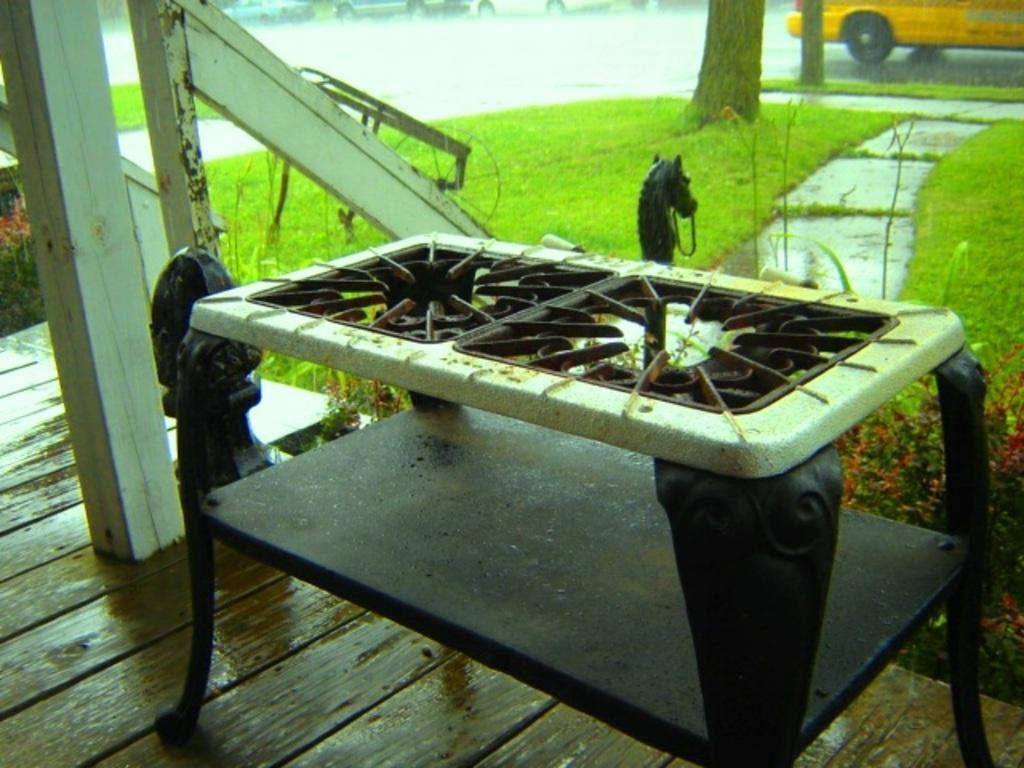Can you describe this image briefly? This picture is clicked outside. In the foreground there is a table to which object is attached. On the left we can see the hand rail and the stairs and there are some objects placed on the ground and we can see the green grass. In the background we can see the vehicles seems to be running on the road and we can see the trunks of the trees. 